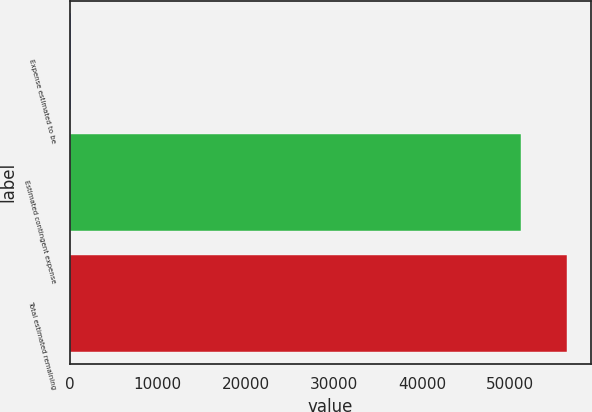Convert chart to OTSL. <chart><loc_0><loc_0><loc_500><loc_500><bar_chart><fcel>Expense estimated to be<fcel>Estimated contingent expense<fcel>Total estimated remaining<nl><fcel>162<fcel>51258<fcel>56383.8<nl></chart> 